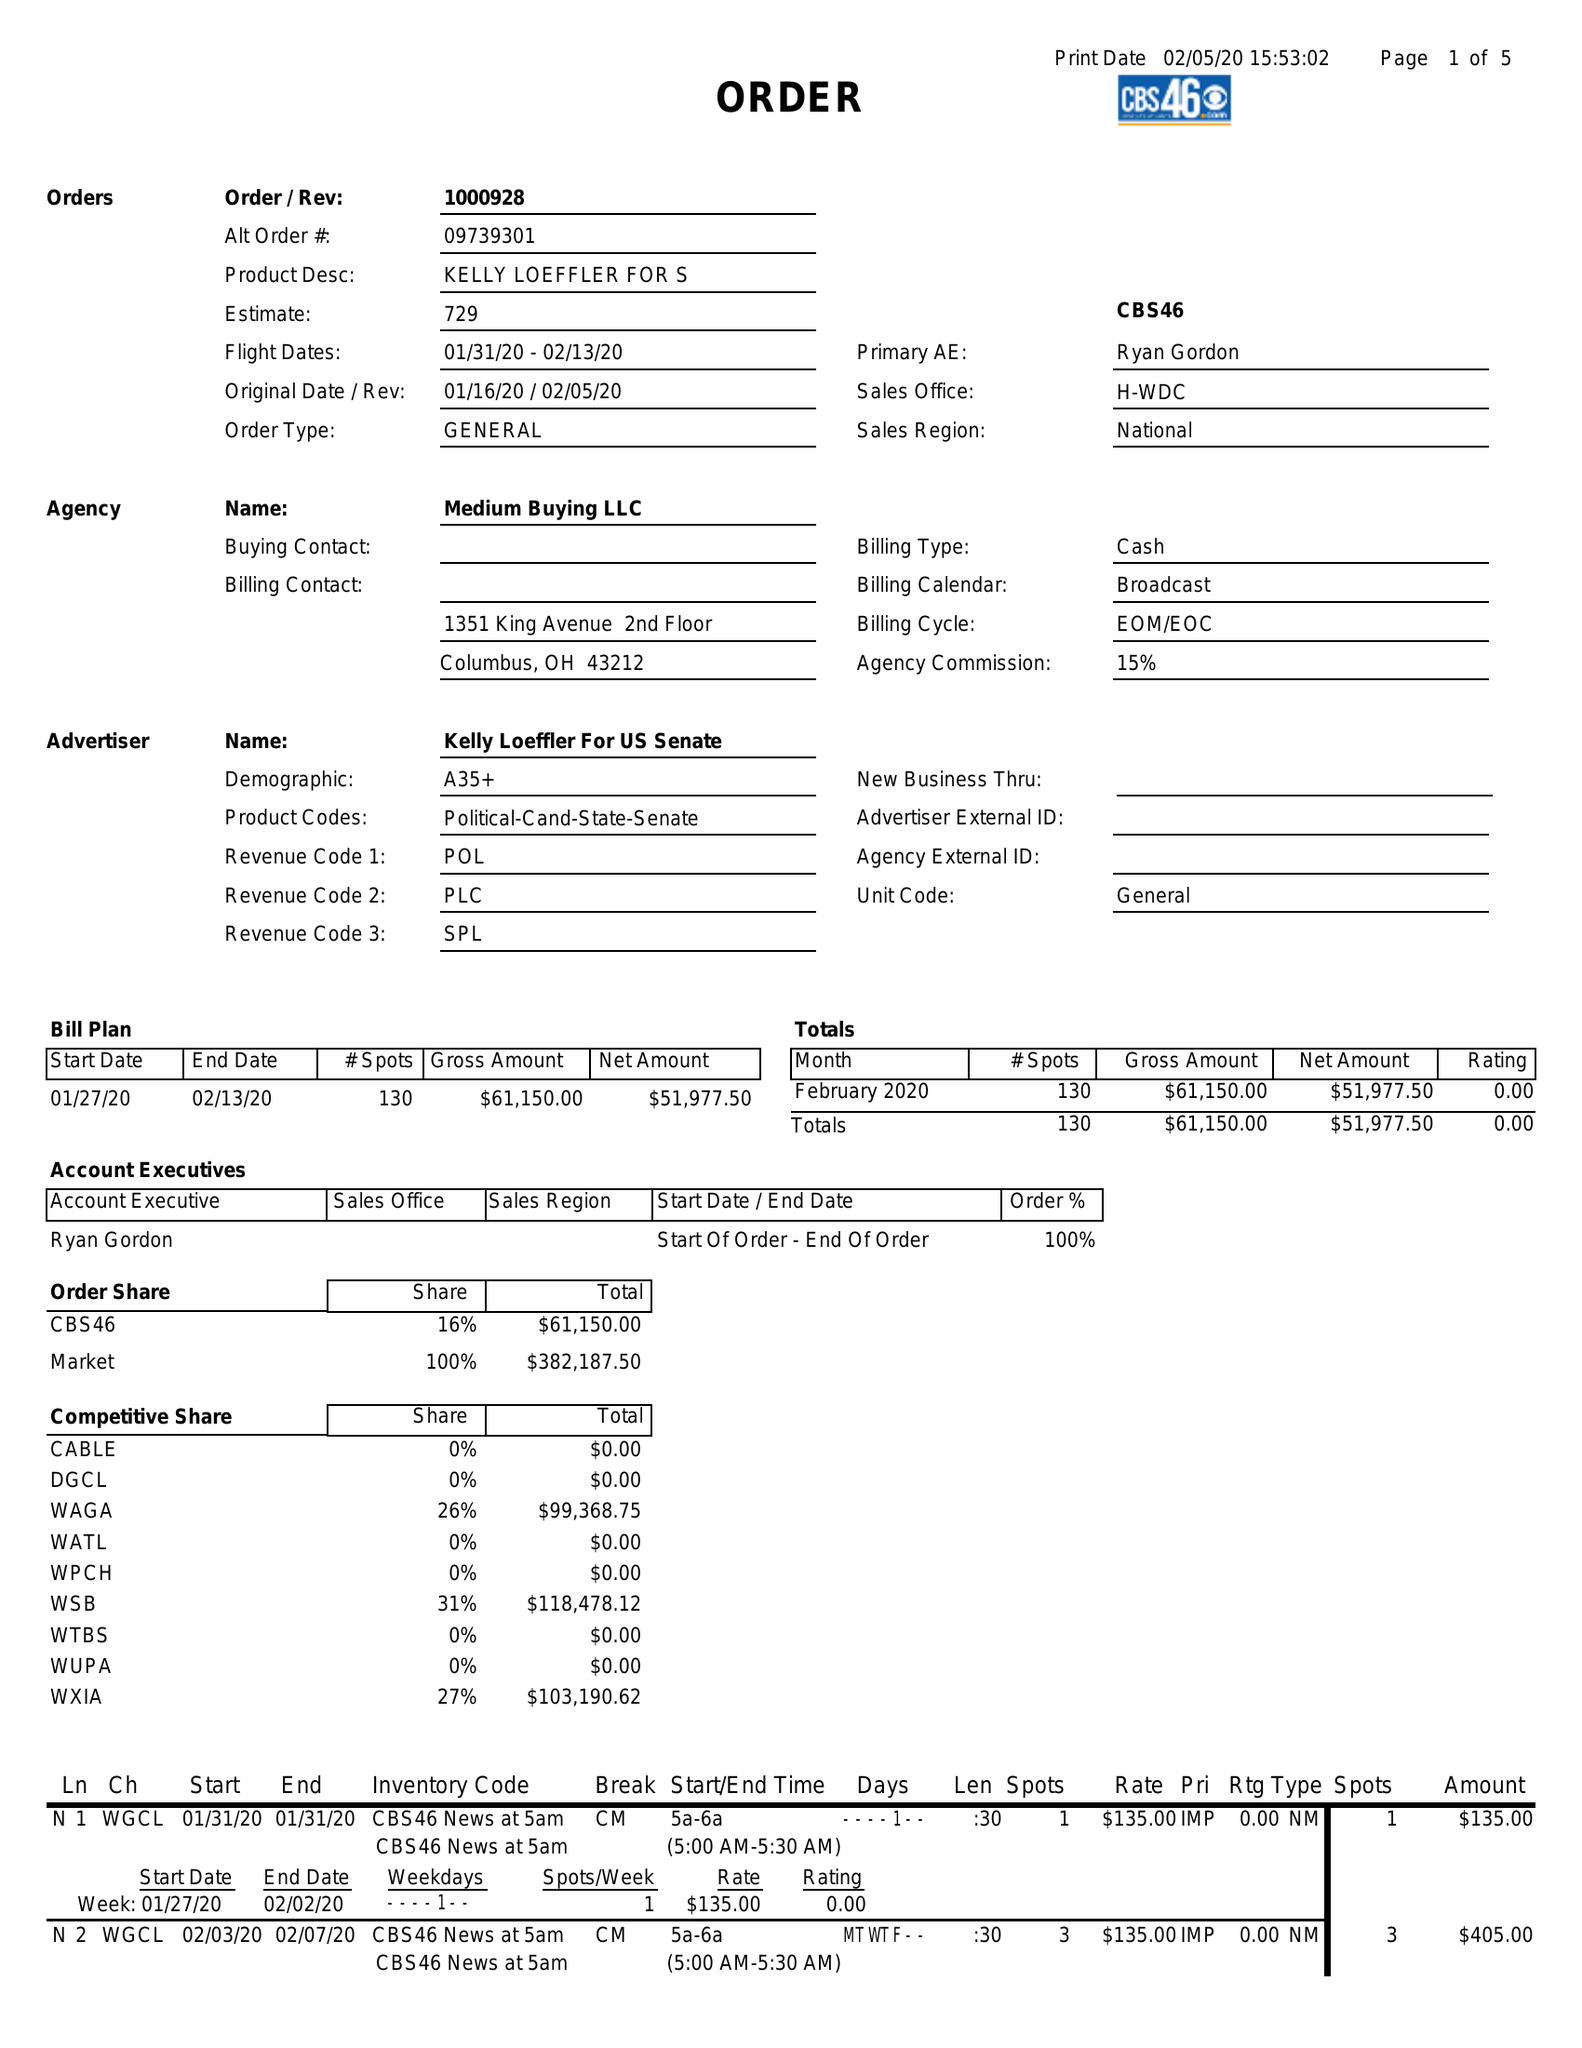What is the value for the flight_to?
Answer the question using a single word or phrase. 02/13/20 